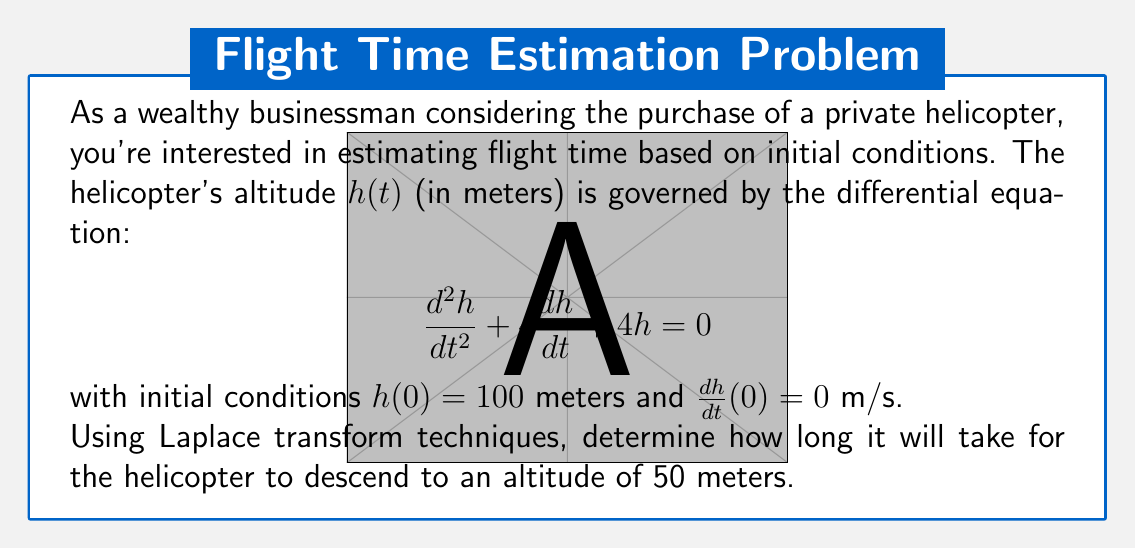What is the answer to this math problem? Let's solve this problem step-by-step using Laplace transforms:

1) Take the Laplace transform of both sides of the differential equation:
   $$\mathcal{L}\{h''(t) + 4h'(t) + 4h(t)\} = \mathcal{L}\{0\}$$

2) Apply Laplace transform properties:
   $$(s^2H(s) - sh(0) - h'(0)) + 4(sH(s) - h(0)) + 4H(s) = 0$$

3) Substitute initial conditions $h(0) = 100$ and $h'(0) = 0$:
   $$(s^2H(s) - 100s) + 4(sH(s) - 100) + 4H(s) = 0$$

4) Simplify and solve for $H(s)$:
   $$s^2H(s) + 4sH(s) + 4H(s) = 100s + 400$$
   $$(s^2 + 4s + 4)H(s) = 100s + 400$$
   $$H(s) = \frac{100s + 400}{s^2 + 4s + 4} = \frac{100(s + 4)}{(s + 2)^2}$$

5) Use partial fraction decomposition:
   $$H(s) = \frac{100}{s + 2} + \frac{200}{(s + 2)^2}$$

6) Take the inverse Laplace transform:
   $$h(t) = 100e^{-2t} + 200te^{-2t}$$

7) To find when $h(t) = 50$, solve:
   $$50 = 100e^{-2t} + 200te^{-2t}$$

8) This transcendental equation can't be solved algebraically. We need to use numerical methods or graphing to find $t \approx 0.3466$ seconds.
Answer: $t \approx 0.3466$ seconds 